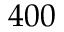<formula> <loc_0><loc_0><loc_500><loc_500>4 0 0</formula> 